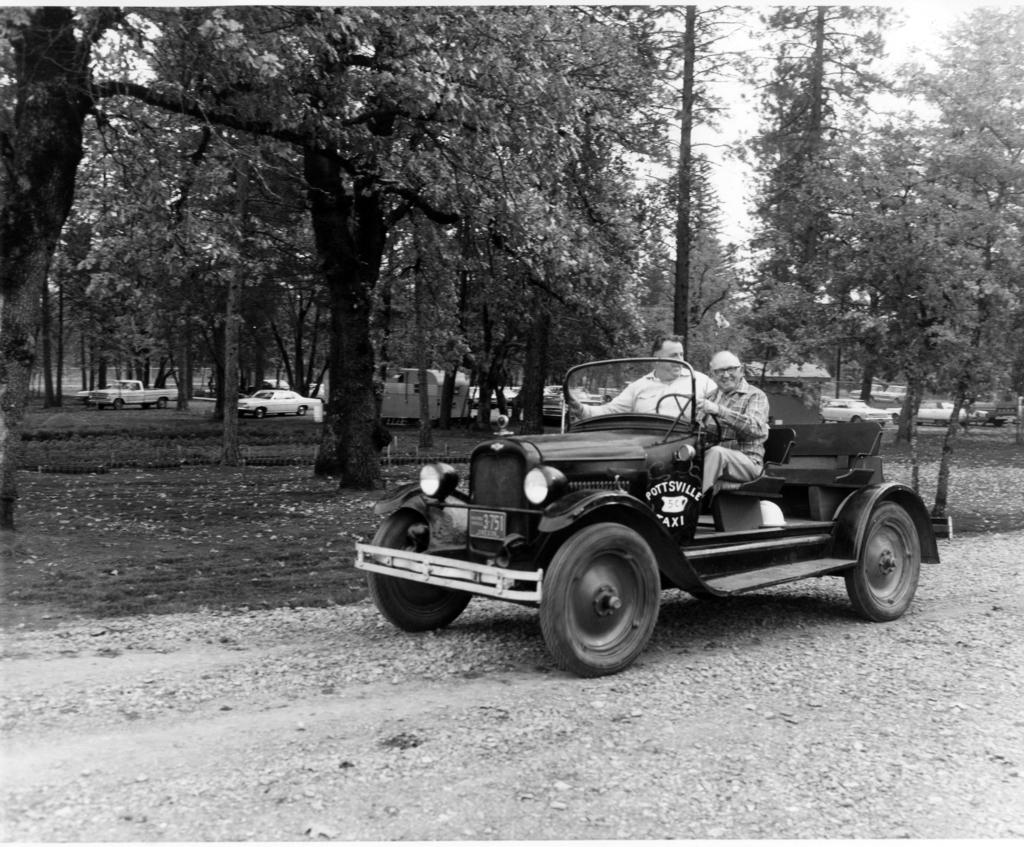How many people are in the image? There are two people in the image. What are the people doing in the image? The people are sitting on a vehicle. What can be seen in the background of the image? There is grass, trees, vehicles, and the sky visible in the image. What type of surface is the vehicle on? The vehicle is on a road, as indicated by the fact that a road is visible in the image. What advice does the crook give to the person in the image? There is no crook or person receiving advice present in the image. What day of the week is it in the image? The day of the week is not mentioned or depicted in the image. 